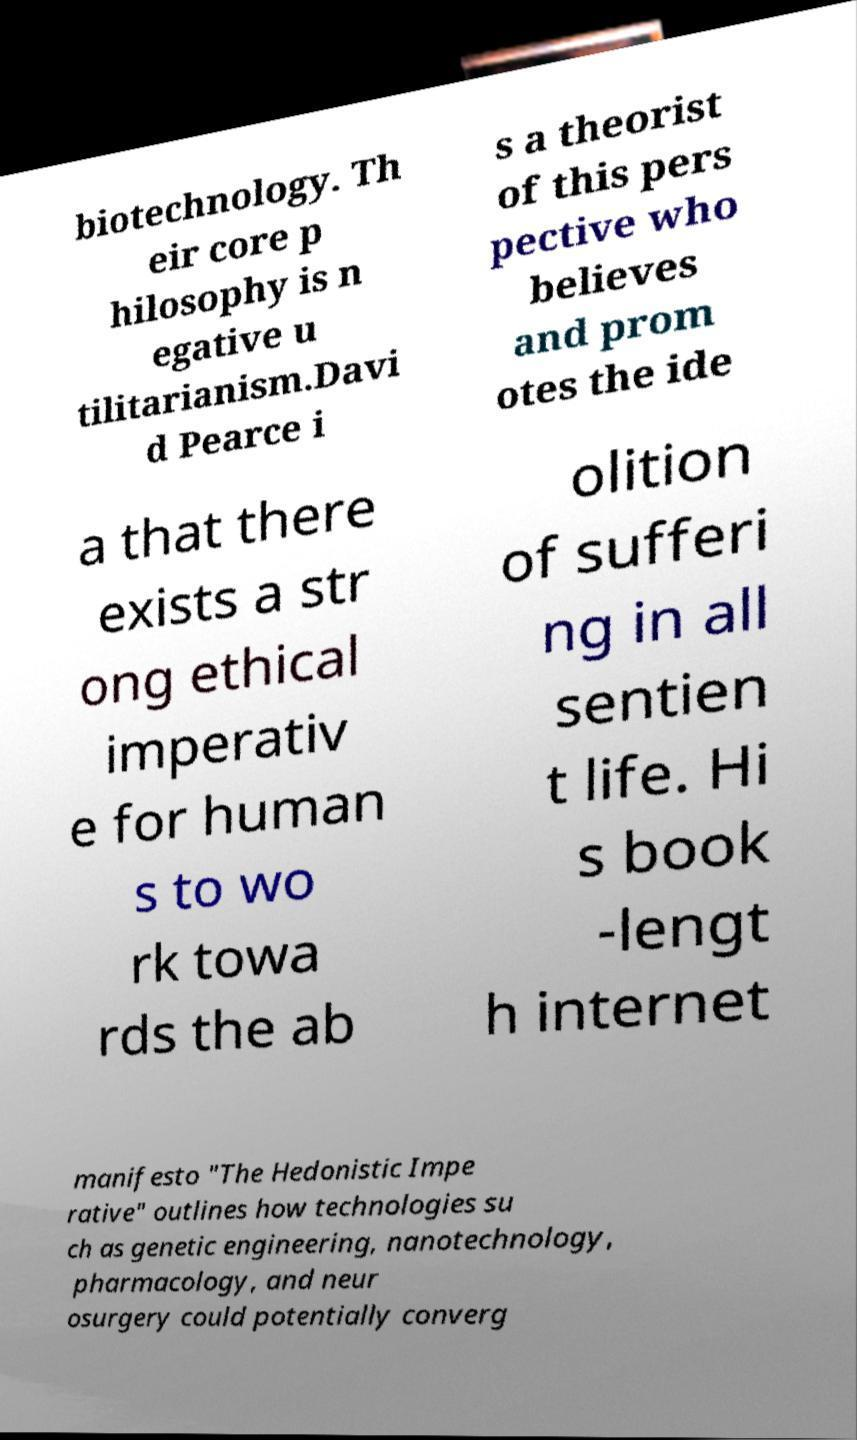Please read and relay the text visible in this image. What does it say? biotechnology. Th eir core p hilosophy is n egative u tilitarianism.Davi d Pearce i s a theorist of this pers pective who believes and prom otes the ide a that there exists a str ong ethical imperativ e for human s to wo rk towa rds the ab olition of sufferi ng in all sentien t life. Hi s book -lengt h internet manifesto "The Hedonistic Impe rative" outlines how technologies su ch as genetic engineering, nanotechnology, pharmacology, and neur osurgery could potentially converg 